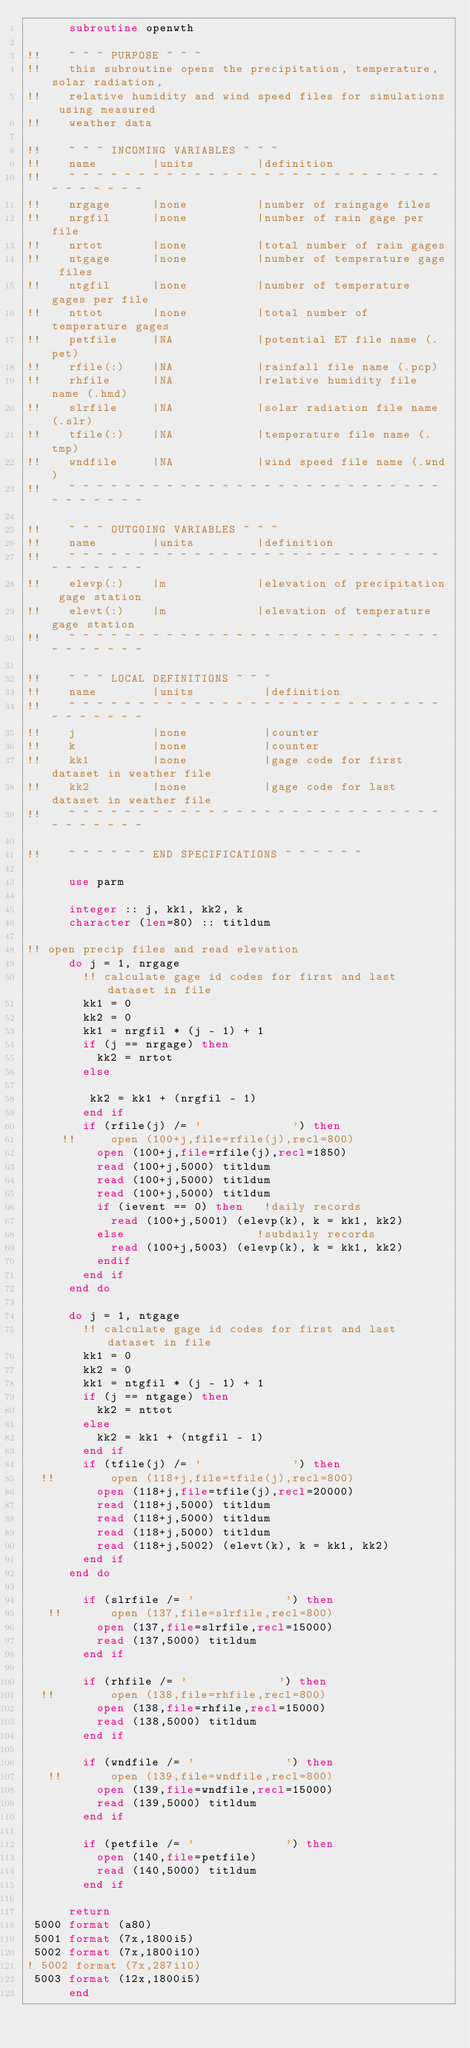Convert code to text. <code><loc_0><loc_0><loc_500><loc_500><_FORTRAN_>      subroutine openwth

!!    ~ ~ ~ PURPOSE ~ ~ ~
!!    this subroutine opens the precipitation, temperature, solar radiation,
!!    relative humidity and wind speed files for simulations using measured 
!!    weather data

!!    ~ ~ ~ INCOMING VARIABLES ~ ~ ~
!!    name        |units         |definition
!!    ~ ~ ~ ~ ~ ~ ~ ~ ~ ~ ~ ~ ~ ~ ~ ~ ~ ~ ~ ~ ~ ~ ~ ~ ~ ~ ~ ~ ~ ~ ~ ~ ~ ~
!!    nrgage      |none          |number of raingage files
!!    nrgfil      |none          |number of rain gage per file
!!    nrtot       |none          |total number of rain gages
!!    ntgage      |none          |number of temperature gage files
!!    ntgfil      |none          |number of temperature gages per file
!!    nttot       |none          |total number of temperature gages
!!    petfile     |NA            |potential ET file name (.pet)
!!    rfile(:)    |NA            |rainfall file name (.pcp)
!!    rhfile      |NA            |relative humidity file name (.hmd)
!!    slrfile     |NA            |solar radiation file name (.slr)
!!    tfile(:)    |NA            |temperature file name (.tmp)
!!    wndfile     |NA            |wind speed file name (.wnd)
!!    ~ ~ ~ ~ ~ ~ ~ ~ ~ ~ ~ ~ ~ ~ ~ ~ ~ ~ ~ ~ ~ ~ ~ ~ ~ ~ ~ ~ ~ ~ ~ ~ ~ ~

!!    ~ ~ ~ OUTGOING VARIABLES ~ ~ ~
!!    name        |units         |definition
!!    ~ ~ ~ ~ ~ ~ ~ ~ ~ ~ ~ ~ ~ ~ ~ ~ ~ ~ ~ ~ ~ ~ ~ ~ ~ ~ ~ ~ ~ ~ ~ ~ ~ ~
!!    elevp(:)    |m             |elevation of precipitation gage station
!!    elevt(:)    |m             |elevation of temperature gage station
!!    ~ ~ ~ ~ ~ ~ ~ ~ ~ ~ ~ ~ ~ ~ ~ ~ ~ ~ ~ ~ ~ ~ ~ ~ ~ ~ ~ ~ ~ ~ ~ ~ ~ ~

!!    ~ ~ ~ LOCAL DEFINITIONS ~ ~ ~
!!    name        |units          |definition
!!    ~ ~ ~ ~ ~ ~ ~ ~ ~ ~ ~ ~ ~ ~ ~ ~ ~ ~ ~ ~ ~ ~ ~ ~ ~ ~ ~ ~ ~ ~ ~ ~ ~ ~
!!    j           |none           |counter
!!    k           |none           |counter
!!    kk1         |none           |gage code for first dataset in weather file
!!    kk2         |none           |gage code for last dataset in weather file
!!    ~ ~ ~ ~ ~ ~ ~ ~ ~ ~ ~ ~ ~ ~ ~ ~ ~ ~ ~ ~ ~ ~ ~ ~ ~ ~ ~ ~ ~ ~ ~ ~ ~ ~

!!    ~ ~ ~ ~ ~ ~ END SPECIFICATIONS ~ ~ ~ ~ ~ ~

      use parm

      integer :: j, kk1, kk2, k
      character (len=80) :: titldum

!! open precip files and read elevation
      do j = 1, nrgage
        !! calculate gage id codes for first and last dataset in file
        kk1 = 0
        kk2 = 0
        kk1 = nrgfil * (j - 1) + 1
        if (j == nrgage) then
          kk2 = nrtot
        else
    
         kk2 = kk1 + (nrgfil - 1)
        end if
        if (rfile(j) /= '             ') then
     !!     open (100+j,file=rfile(j),recl=800)
          open (100+j,file=rfile(j),recl=1850)
          read (100+j,5000) titldum
          read (100+j,5000) titldum
          read (100+j,5000) titldum
          if (ievent == 0) then   !daily records
            read (100+j,5001) (elevp(k), k = kk1, kk2)
          else                   !subdaily records
            read (100+j,5003) (elevp(k), k = kk1, kk2)
          endif
        end if
      end do

      do j = 1, ntgage
        !! calculate gage id codes for first and last dataset in file
        kk1 = 0
        kk2 = 0
        kk1 = ntgfil * (j - 1) + 1
        if (j == ntgage) then
          kk2 = nttot
        else
          kk2 = kk1 + (ntgfil - 1)
        end if
        if (tfile(j) /= '             ') then
  !!        open (118+j,file=tfile(j),recl=800)
          open (118+j,file=tfile(j),recl=20000)
          read (118+j,5000) titldum
          read (118+j,5000) titldum
          read (118+j,5000) titldum
          read (118+j,5002) (elevt(k), k = kk1, kk2)
        end if
      end do

        if (slrfile /= '             ') then
   !!       open (137,file=slrfile,recl=800)
          open (137,file=slrfile,recl=15000)
          read (137,5000) titldum
        end if

        if (rhfile /= '             ') then
  !!        open (138,file=rhfile,recl=800)
          open (138,file=rhfile,recl=15000)
          read (138,5000) titldum
        end if

        if (wndfile /= '             ') then
   !!       open (139,file=wndfile,recl=800)
          open (139,file=wndfile,recl=15000)
          read (139,5000) titldum
        end if

        if (petfile /= '             ') then
          open (140,file=petfile)
          read (140,5000) titldum
        end if

      return
 5000 format (a80)
 5001 format (7x,1800i5)
 5002 format (7x,1800i10)   
! 5002 format (7x,287i10)
 5003 format (12x,1800i5)
      end</code> 